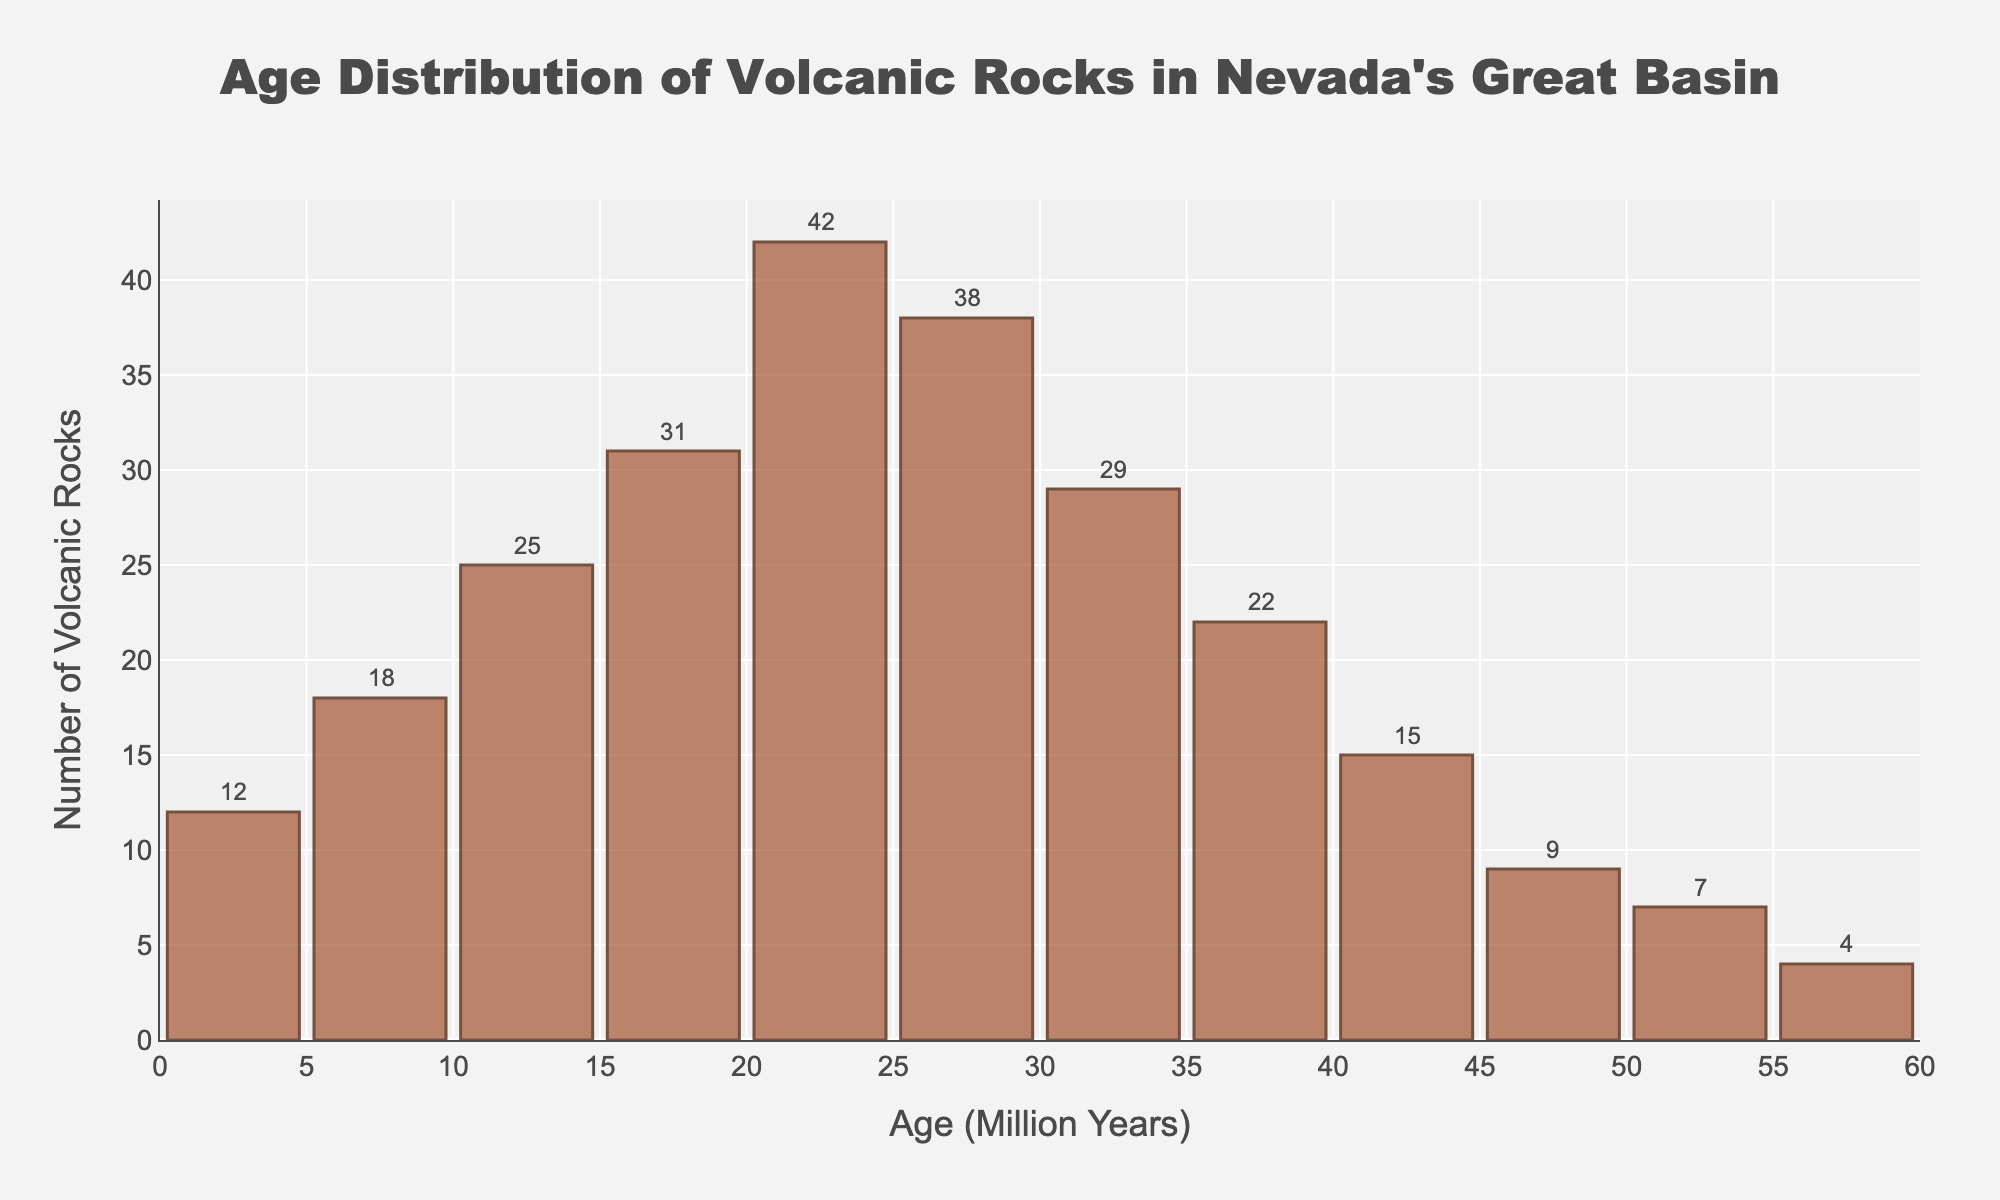What is the title of the histogram? The title is displayed at the top of the histogram and provides a summary of what the chart represents.
Answer: Age Distribution of Volcanic Rocks in Nevada's Great Basin What is the age range with the highest number of volcanic rocks? To find this, we need to look for the bar with the tallest height and check the corresponding age range on the x-axis. The bar at 20-25 million years is the tallest.
Answer: 20-25 million years What is the age range with the lowest number of volcanic rocks? To find this, we need to look for the bar with the shortest height and check the corresponding age range on the x-axis. The bar at 55-60 million years is the shortest.
Answer: 55-60 million years How many volcanic rocks are there in the 30-35 million years age range? Locate the bar corresponding to the 30-35 million years range on the x-axis. The height indicates the number of volcanic rocks, which is 29.
Answer: 29 Is the number of volcanic rocks aged 20-25 million years greater than those aged 40-45 million years? The height of the bar for the 20-25 million years range is taller than that for the 40-45 million years range, indicating a larger number of volcanic rocks.
Answer: Yes Which age range has more volcanic rocks: 5-10 million years or 50-55 million years? Compare the heights of the bars corresponding to the 5-10 and 50-55 million years age ranges. The 5-10 million years range has a taller bar.
Answer: 5-10 million years What is the total number of volcanic rocks sampled? Sum up the number of volcanic rocks in all age ranges: 12 + 18 + 25 + 31 + 42 + 38 + 29 + 22 + 15 + 9 + 7 + 4 = 252.
Answer: 252 By how many do the volcanic rocks aged 20-25 million years exceed those aged 45-50 million years? Subtract the number of volcanic rocks in the 45-50 million years range (9) from those in the 20-25 million years range (42): 42 - 9 = 33.
Answer: 33 What's the average number of volcanic rocks across all age ranges? Find the total number of volcanic rocks (252) and divide by the number of age ranges (12): 252/12 = 21.
Answer: 21 